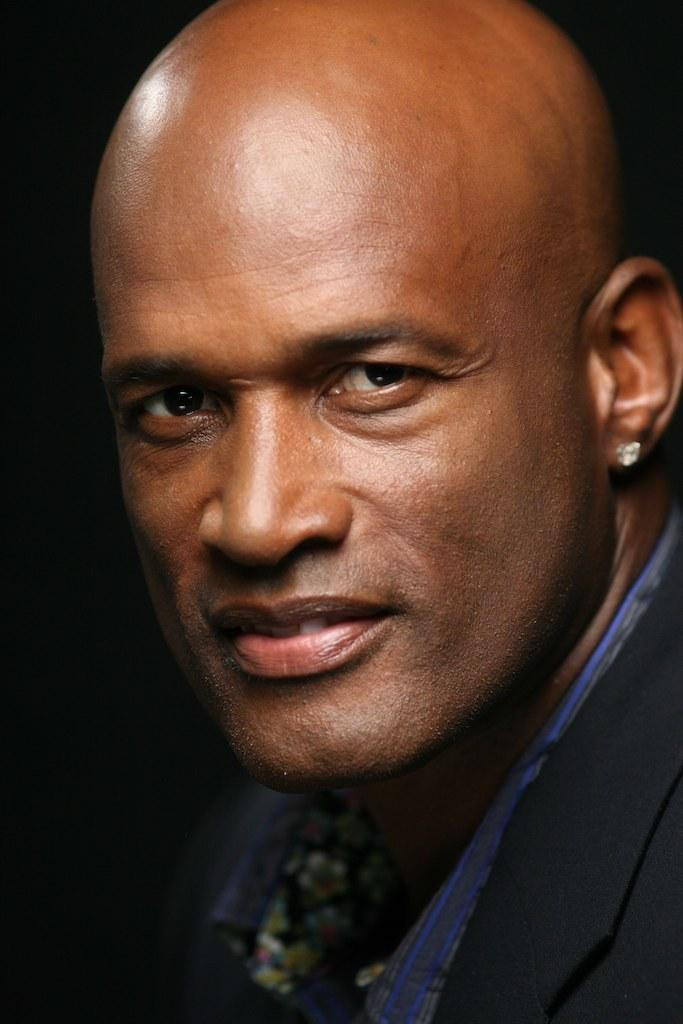What is the expression on the person's face in the image? The person is smiling. Can you describe the background of the image? The background is dark. What type of popcorn is being served in the image? There is no popcorn present in the image. How does the sleet affect the person's clothing in the image? There is no sleet present in the image, so it cannot affect the person's clothing. 